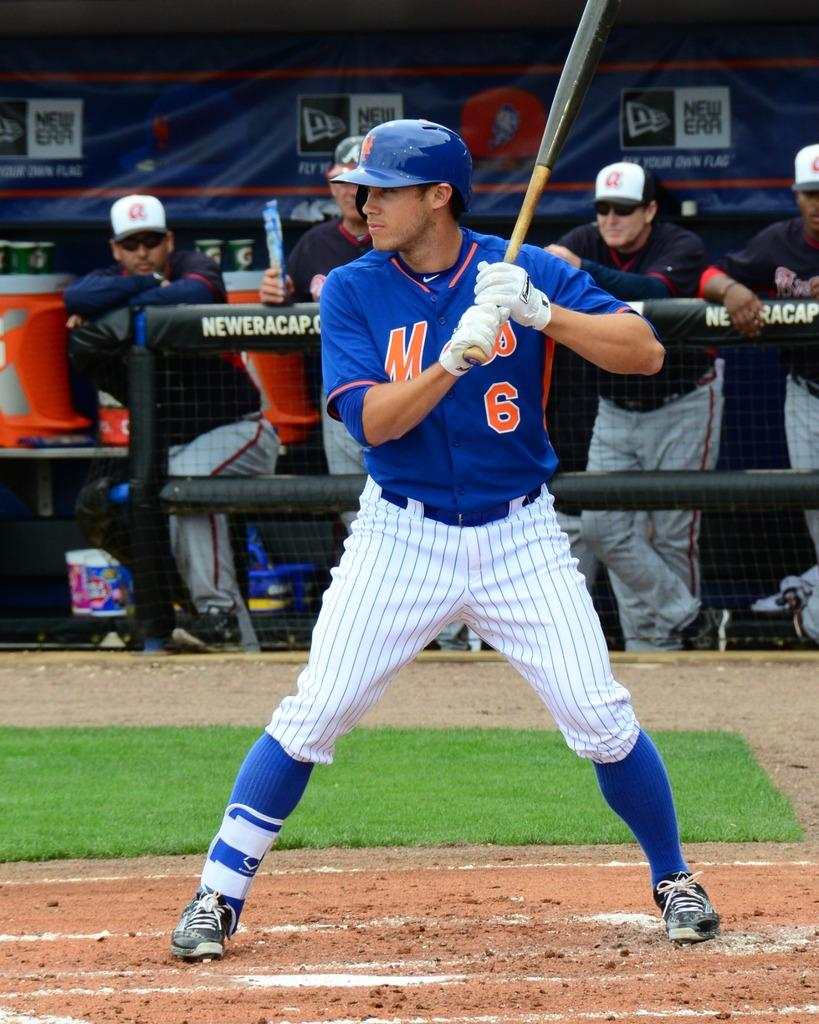Provide a one-sentence caption for the provided image. The batther is in a batting stance on the baseball field and is wearing a blue number uniform. 